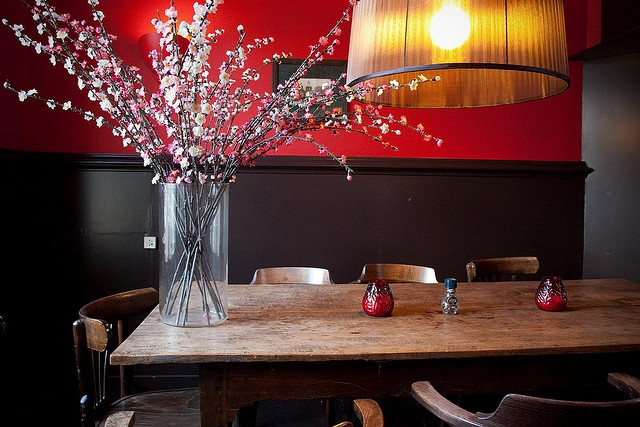Describe the objects in this image and their specific colors. I can see dining table in black, maroon, brown, and darkgray tones, vase in black, gray, darkgray, and lightgray tones, chair in black, maroon, and gray tones, chair in black, gray, and darkgray tones, and chair in black, maroon, and brown tones in this image. 